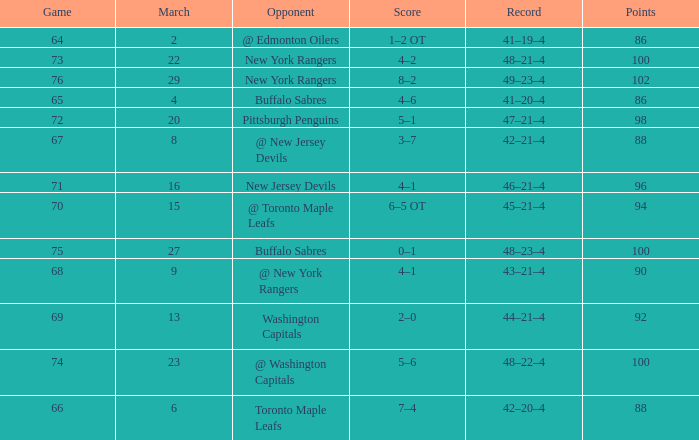Which Opponent has a Record of 45–21–4? @ Toronto Maple Leafs. 